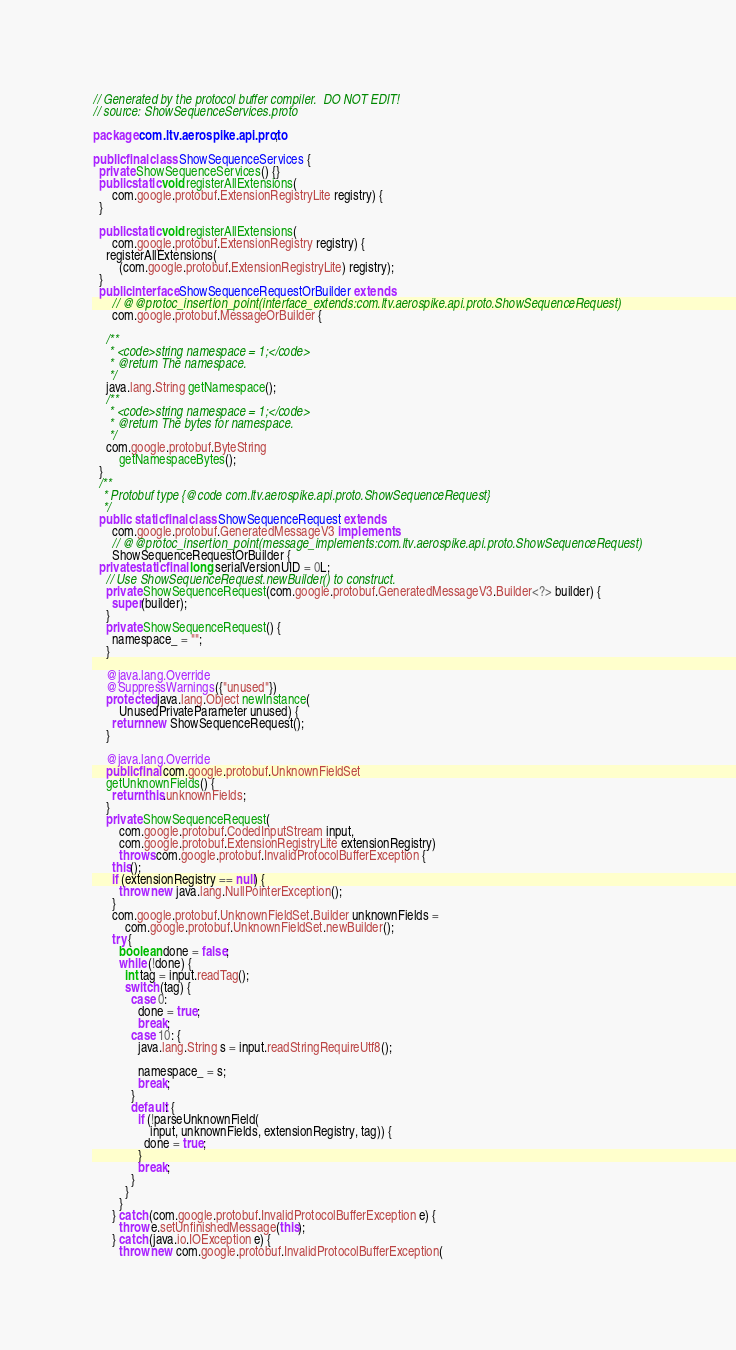Convert code to text. <code><loc_0><loc_0><loc_500><loc_500><_Java_>// Generated by the protocol buffer compiler.  DO NOT EDIT!
// source: ShowSequenceServices.proto

package com.ltv.aerospike.api.proto;

public final class ShowSequenceServices {
  private ShowSequenceServices() {}
  public static void registerAllExtensions(
      com.google.protobuf.ExtensionRegistryLite registry) {
  }

  public static void registerAllExtensions(
      com.google.protobuf.ExtensionRegistry registry) {
    registerAllExtensions(
        (com.google.protobuf.ExtensionRegistryLite) registry);
  }
  public interface ShowSequenceRequestOrBuilder extends
      // @@protoc_insertion_point(interface_extends:com.ltv.aerospike.api.proto.ShowSequenceRequest)
      com.google.protobuf.MessageOrBuilder {

    /**
     * <code>string namespace = 1;</code>
     * @return The namespace.
     */
    java.lang.String getNamespace();
    /**
     * <code>string namespace = 1;</code>
     * @return The bytes for namespace.
     */
    com.google.protobuf.ByteString
        getNamespaceBytes();
  }
  /**
   * Protobuf type {@code com.ltv.aerospike.api.proto.ShowSequenceRequest}
   */
  public  static final class ShowSequenceRequest extends
      com.google.protobuf.GeneratedMessageV3 implements
      // @@protoc_insertion_point(message_implements:com.ltv.aerospike.api.proto.ShowSequenceRequest)
      ShowSequenceRequestOrBuilder {
  private static final long serialVersionUID = 0L;
    // Use ShowSequenceRequest.newBuilder() to construct.
    private ShowSequenceRequest(com.google.protobuf.GeneratedMessageV3.Builder<?> builder) {
      super(builder);
    }
    private ShowSequenceRequest() {
      namespace_ = "";
    }

    @java.lang.Override
    @SuppressWarnings({"unused"})
    protected java.lang.Object newInstance(
        UnusedPrivateParameter unused) {
      return new ShowSequenceRequest();
    }

    @java.lang.Override
    public final com.google.protobuf.UnknownFieldSet
    getUnknownFields() {
      return this.unknownFields;
    }
    private ShowSequenceRequest(
        com.google.protobuf.CodedInputStream input,
        com.google.protobuf.ExtensionRegistryLite extensionRegistry)
        throws com.google.protobuf.InvalidProtocolBufferException {
      this();
      if (extensionRegistry == null) {
        throw new java.lang.NullPointerException();
      }
      com.google.protobuf.UnknownFieldSet.Builder unknownFields =
          com.google.protobuf.UnknownFieldSet.newBuilder();
      try {
        boolean done = false;
        while (!done) {
          int tag = input.readTag();
          switch (tag) {
            case 0:
              done = true;
              break;
            case 10: {
              java.lang.String s = input.readStringRequireUtf8();

              namespace_ = s;
              break;
            }
            default: {
              if (!parseUnknownField(
                  input, unknownFields, extensionRegistry, tag)) {
                done = true;
              }
              break;
            }
          }
        }
      } catch (com.google.protobuf.InvalidProtocolBufferException e) {
        throw e.setUnfinishedMessage(this);
      } catch (java.io.IOException e) {
        throw new com.google.protobuf.InvalidProtocolBufferException(</code> 